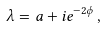Convert formula to latex. <formula><loc_0><loc_0><loc_500><loc_500>\lambda = a + i e ^ { - 2 \phi } \, ,</formula> 